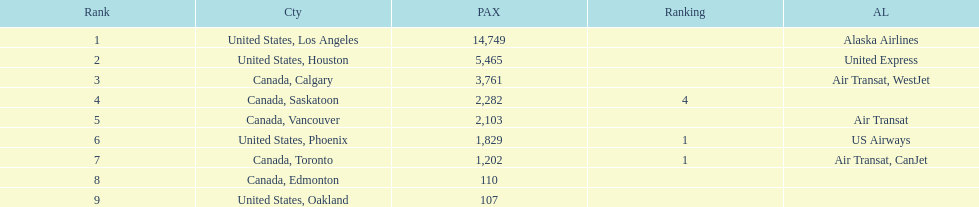What is the average number of passengers in the united states? 5537.5. 